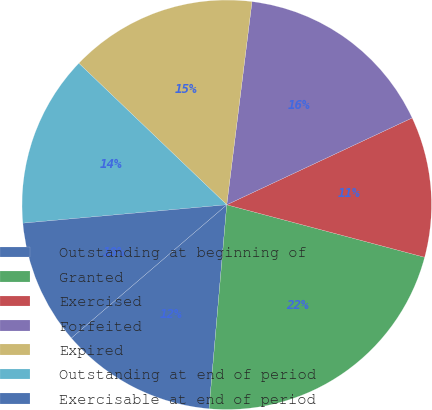<chart> <loc_0><loc_0><loc_500><loc_500><pie_chart><fcel>Outstanding at beginning of<fcel>Granted<fcel>Exercised<fcel>Forfeited<fcel>Expired<fcel>Outstanding at end of period<fcel>Exercisable at end of period<nl><fcel>12.34%<fcel>22.25%<fcel>11.1%<fcel>16.06%<fcel>14.82%<fcel>13.58%<fcel>9.85%<nl></chart> 